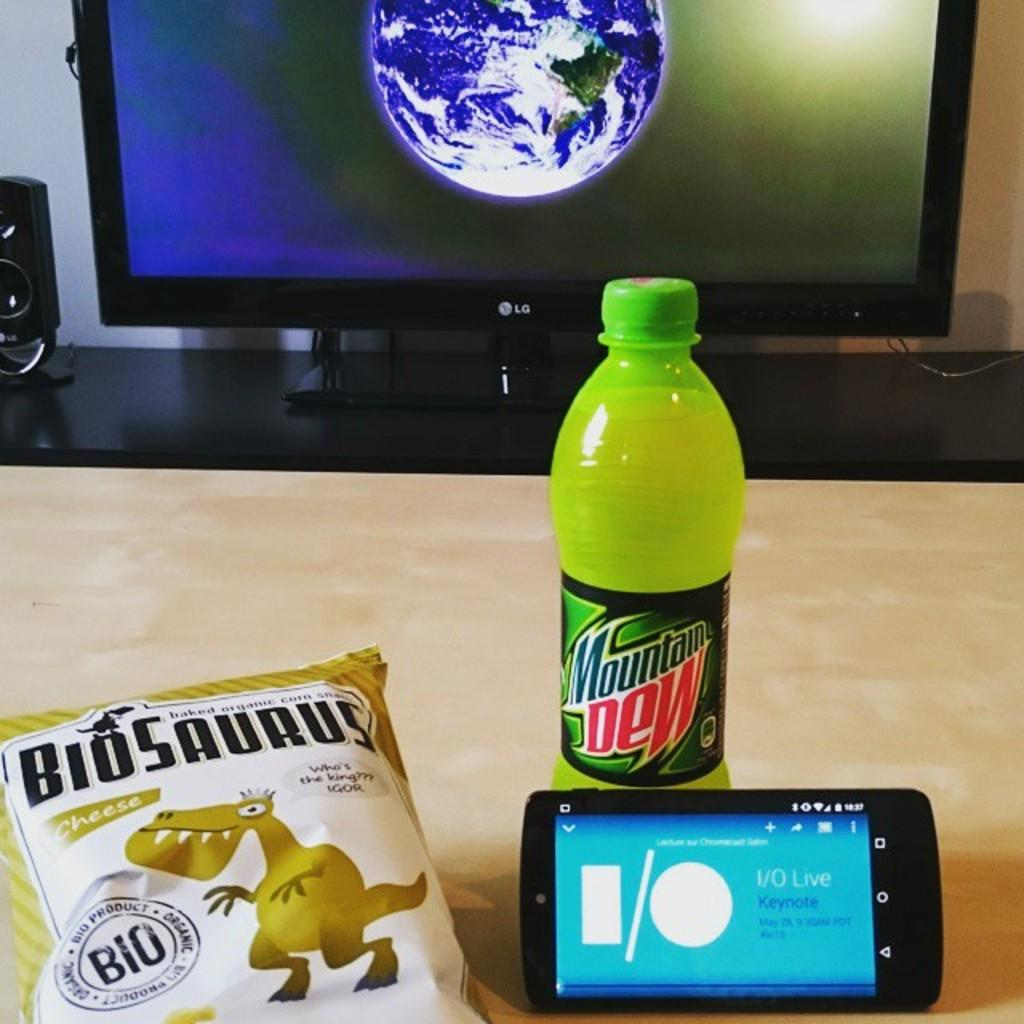Provide a one-sentence caption for the provided image. Tv screen with a cell phone, Mountain Dew drink and Biosaurus snacks nearby. 